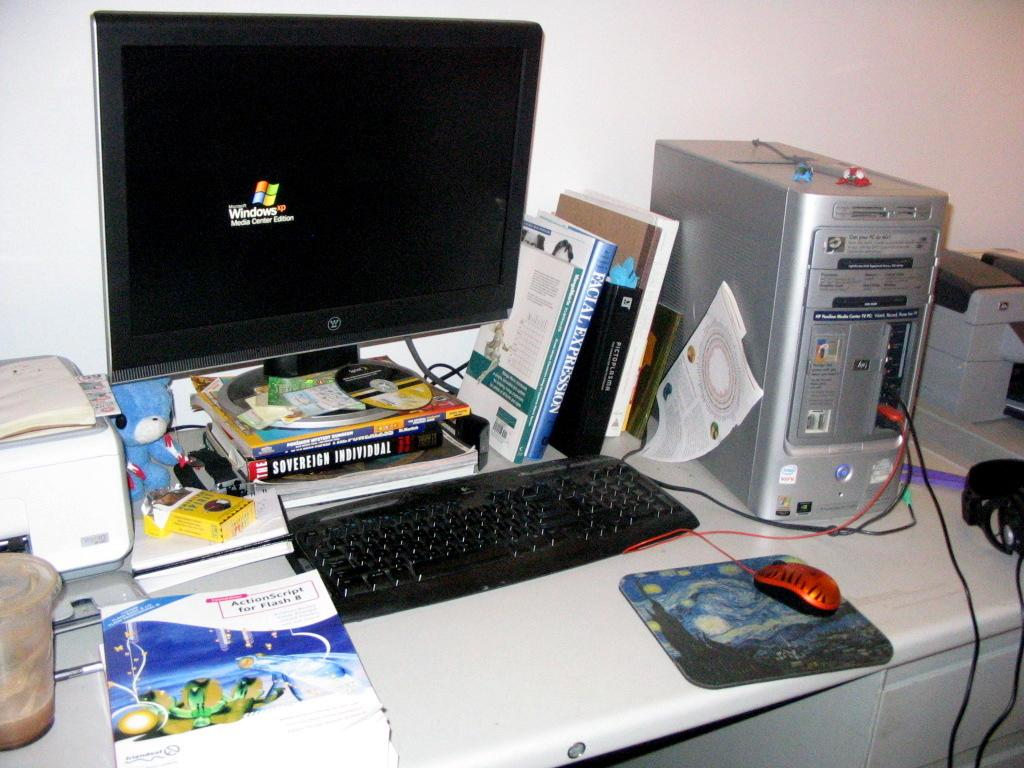Provide a one-sentence caption for the provided image. A book with a title cover that reads ActionScript for Flash 8. 